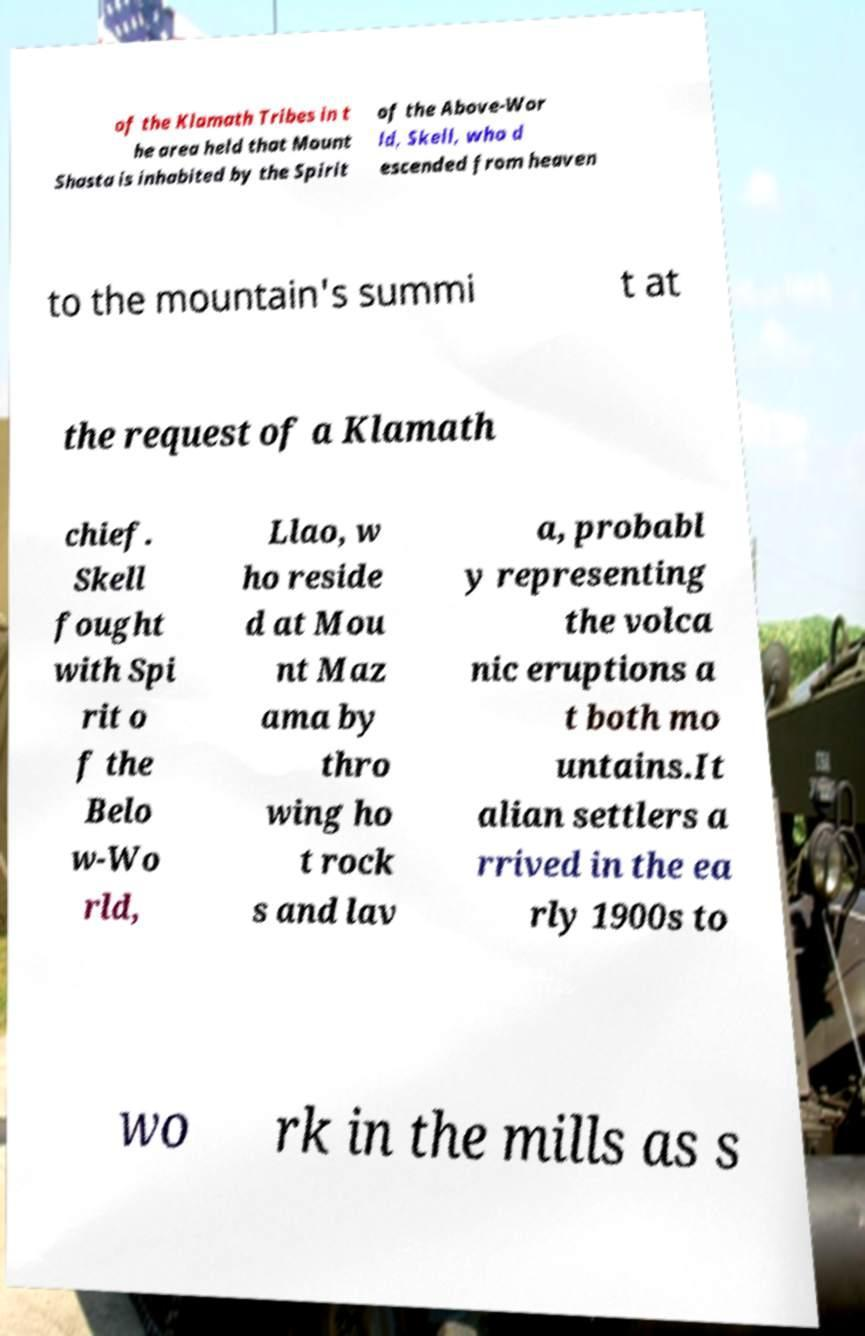I need the written content from this picture converted into text. Can you do that? of the Klamath Tribes in t he area held that Mount Shasta is inhabited by the Spirit of the Above-Wor ld, Skell, who d escended from heaven to the mountain's summi t at the request of a Klamath chief. Skell fought with Spi rit o f the Belo w-Wo rld, Llao, w ho reside d at Mou nt Maz ama by thro wing ho t rock s and lav a, probabl y representing the volca nic eruptions a t both mo untains.It alian settlers a rrived in the ea rly 1900s to wo rk in the mills as s 